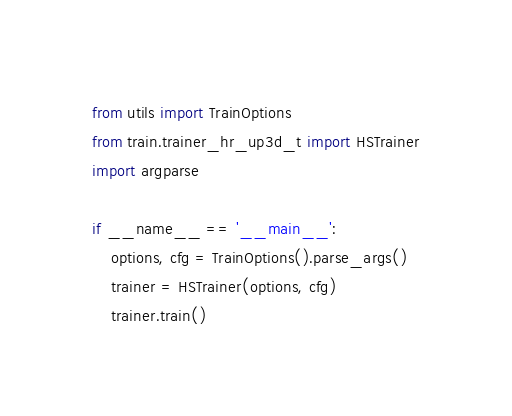<code> <loc_0><loc_0><loc_500><loc_500><_Python_>from utils import TrainOptions
from train.trainer_hr_up3d_t import HSTrainer
import argparse

if __name__ == '__main__':
    options, cfg = TrainOptions().parse_args()
    trainer = HSTrainer(options, cfg)
    trainer.train()
</code> 